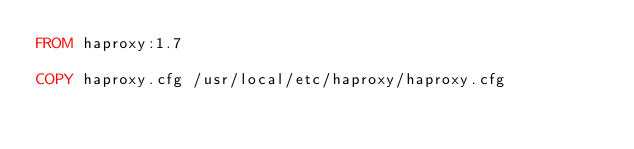Convert code to text. <code><loc_0><loc_0><loc_500><loc_500><_Dockerfile_>FROM haproxy:1.7

COPY haproxy.cfg /usr/local/etc/haproxy/haproxy.cfg</code> 